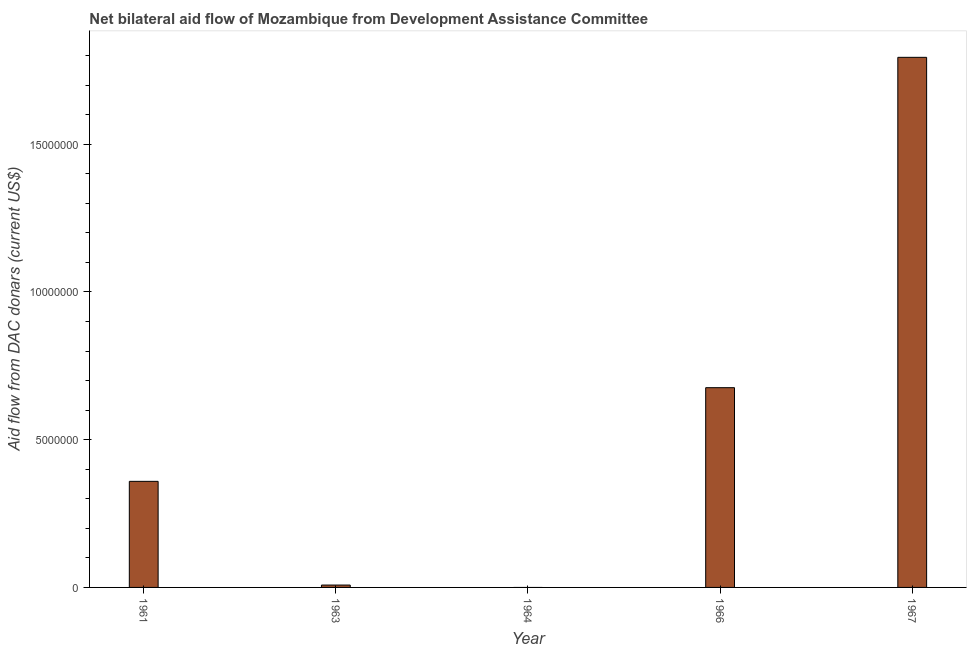Does the graph contain any zero values?
Provide a succinct answer. Yes. What is the title of the graph?
Make the answer very short. Net bilateral aid flow of Mozambique from Development Assistance Committee. What is the label or title of the Y-axis?
Keep it short and to the point. Aid flow from DAC donars (current US$). What is the net bilateral aid flows from dac donors in 1961?
Your response must be concise. 3.59e+06. Across all years, what is the maximum net bilateral aid flows from dac donors?
Your response must be concise. 1.79e+07. In which year was the net bilateral aid flows from dac donors maximum?
Offer a very short reply. 1967. What is the sum of the net bilateral aid flows from dac donors?
Your response must be concise. 2.84e+07. What is the difference between the net bilateral aid flows from dac donors in 1963 and 1967?
Your answer should be very brief. -1.79e+07. What is the average net bilateral aid flows from dac donors per year?
Your response must be concise. 5.67e+06. What is the median net bilateral aid flows from dac donors?
Provide a short and direct response. 3.59e+06. What is the ratio of the net bilateral aid flows from dac donors in 1961 to that in 1966?
Provide a succinct answer. 0.53. What is the difference between the highest and the second highest net bilateral aid flows from dac donors?
Provide a short and direct response. 1.12e+07. What is the difference between the highest and the lowest net bilateral aid flows from dac donors?
Provide a short and direct response. 1.79e+07. What is the difference between two consecutive major ticks on the Y-axis?
Offer a very short reply. 5.00e+06. What is the Aid flow from DAC donars (current US$) in 1961?
Your answer should be very brief. 3.59e+06. What is the Aid flow from DAC donars (current US$) in 1963?
Your response must be concise. 8.00e+04. What is the Aid flow from DAC donars (current US$) in 1964?
Keep it short and to the point. 0. What is the Aid flow from DAC donars (current US$) of 1966?
Provide a succinct answer. 6.76e+06. What is the Aid flow from DAC donars (current US$) in 1967?
Make the answer very short. 1.79e+07. What is the difference between the Aid flow from DAC donars (current US$) in 1961 and 1963?
Keep it short and to the point. 3.51e+06. What is the difference between the Aid flow from DAC donars (current US$) in 1961 and 1966?
Your answer should be compact. -3.17e+06. What is the difference between the Aid flow from DAC donars (current US$) in 1961 and 1967?
Provide a short and direct response. -1.44e+07. What is the difference between the Aid flow from DAC donars (current US$) in 1963 and 1966?
Offer a terse response. -6.68e+06. What is the difference between the Aid flow from DAC donars (current US$) in 1963 and 1967?
Your response must be concise. -1.79e+07. What is the difference between the Aid flow from DAC donars (current US$) in 1966 and 1967?
Offer a terse response. -1.12e+07. What is the ratio of the Aid flow from DAC donars (current US$) in 1961 to that in 1963?
Offer a terse response. 44.88. What is the ratio of the Aid flow from DAC donars (current US$) in 1961 to that in 1966?
Provide a short and direct response. 0.53. What is the ratio of the Aid flow from DAC donars (current US$) in 1963 to that in 1966?
Your response must be concise. 0.01. What is the ratio of the Aid flow from DAC donars (current US$) in 1963 to that in 1967?
Make the answer very short. 0. What is the ratio of the Aid flow from DAC donars (current US$) in 1966 to that in 1967?
Your response must be concise. 0.38. 